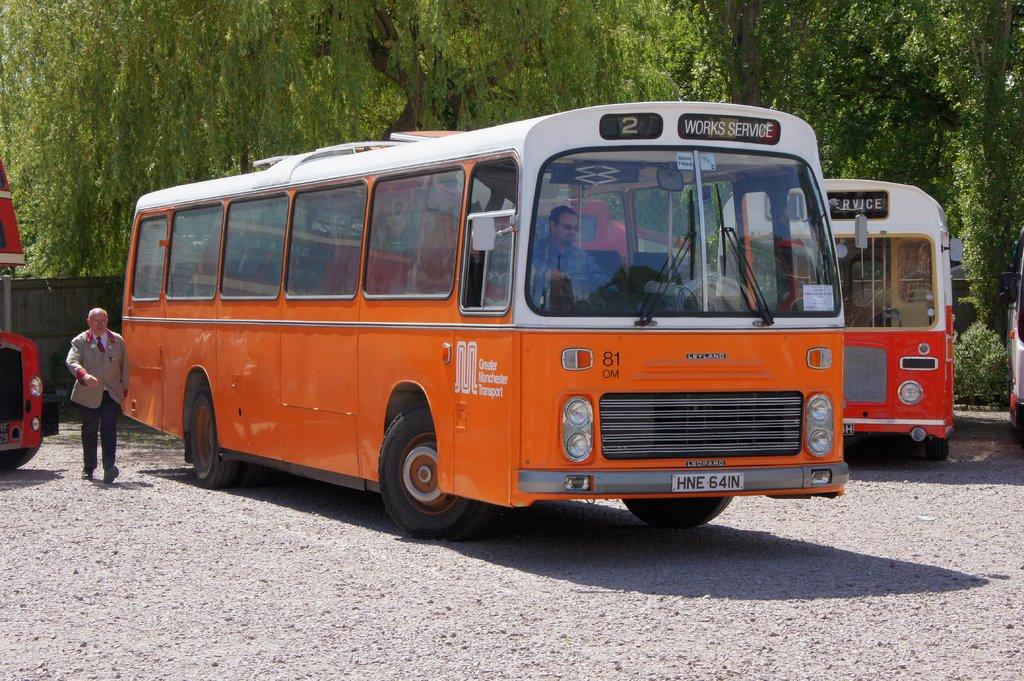What bus number?
Offer a very short reply. 2. What is the liscense plate of the bus?
Ensure brevity in your answer.  Hne 64in. 